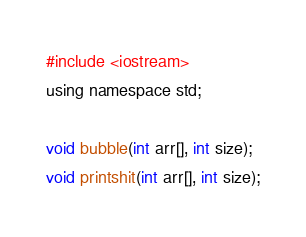<code> <loc_0><loc_0><loc_500><loc_500><_C_>#include <iostream>
using namespace std;

void bubble(int arr[], int size);
void printshit(int arr[], int size);</code> 